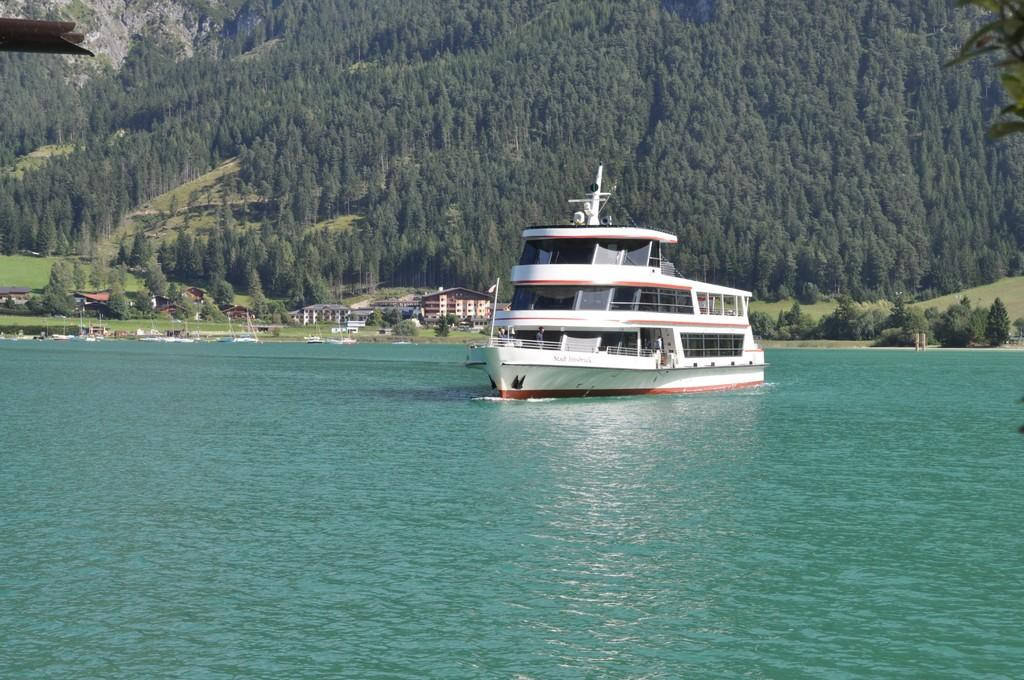What is the main subject of the image? The main subject of the image is a ship. Where is the ship located in the image? The ship is on the water in the center of the image. What can be seen in the background of the image? In the background of the image, there are trees, grass, plants, poles, and buildings. What type of medical advice does the doctor give to the bee in the image? There is no doctor or bee present in the image; it features a ship on the water with a background of trees, grass, plants, poles, and buildings. 